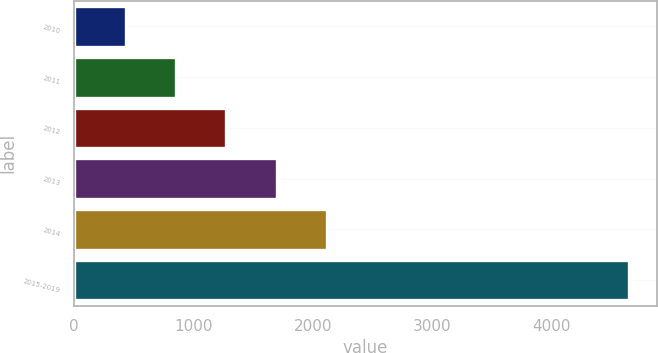Convert chart to OTSL. <chart><loc_0><loc_0><loc_500><loc_500><bar_chart><fcel>2010<fcel>2011<fcel>2012<fcel>2013<fcel>2014<fcel>2015-2019<nl><fcel>432<fcel>854.2<fcel>1276.4<fcel>1698.6<fcel>2120.8<fcel>4654<nl></chart> 